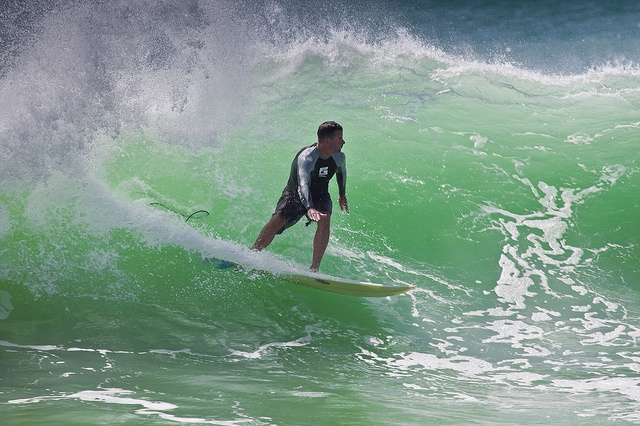Describe the objects in this image and their specific colors. I can see people in gray, black, and darkgray tones and surfboard in gray, darkgreen, darkgray, and green tones in this image. 